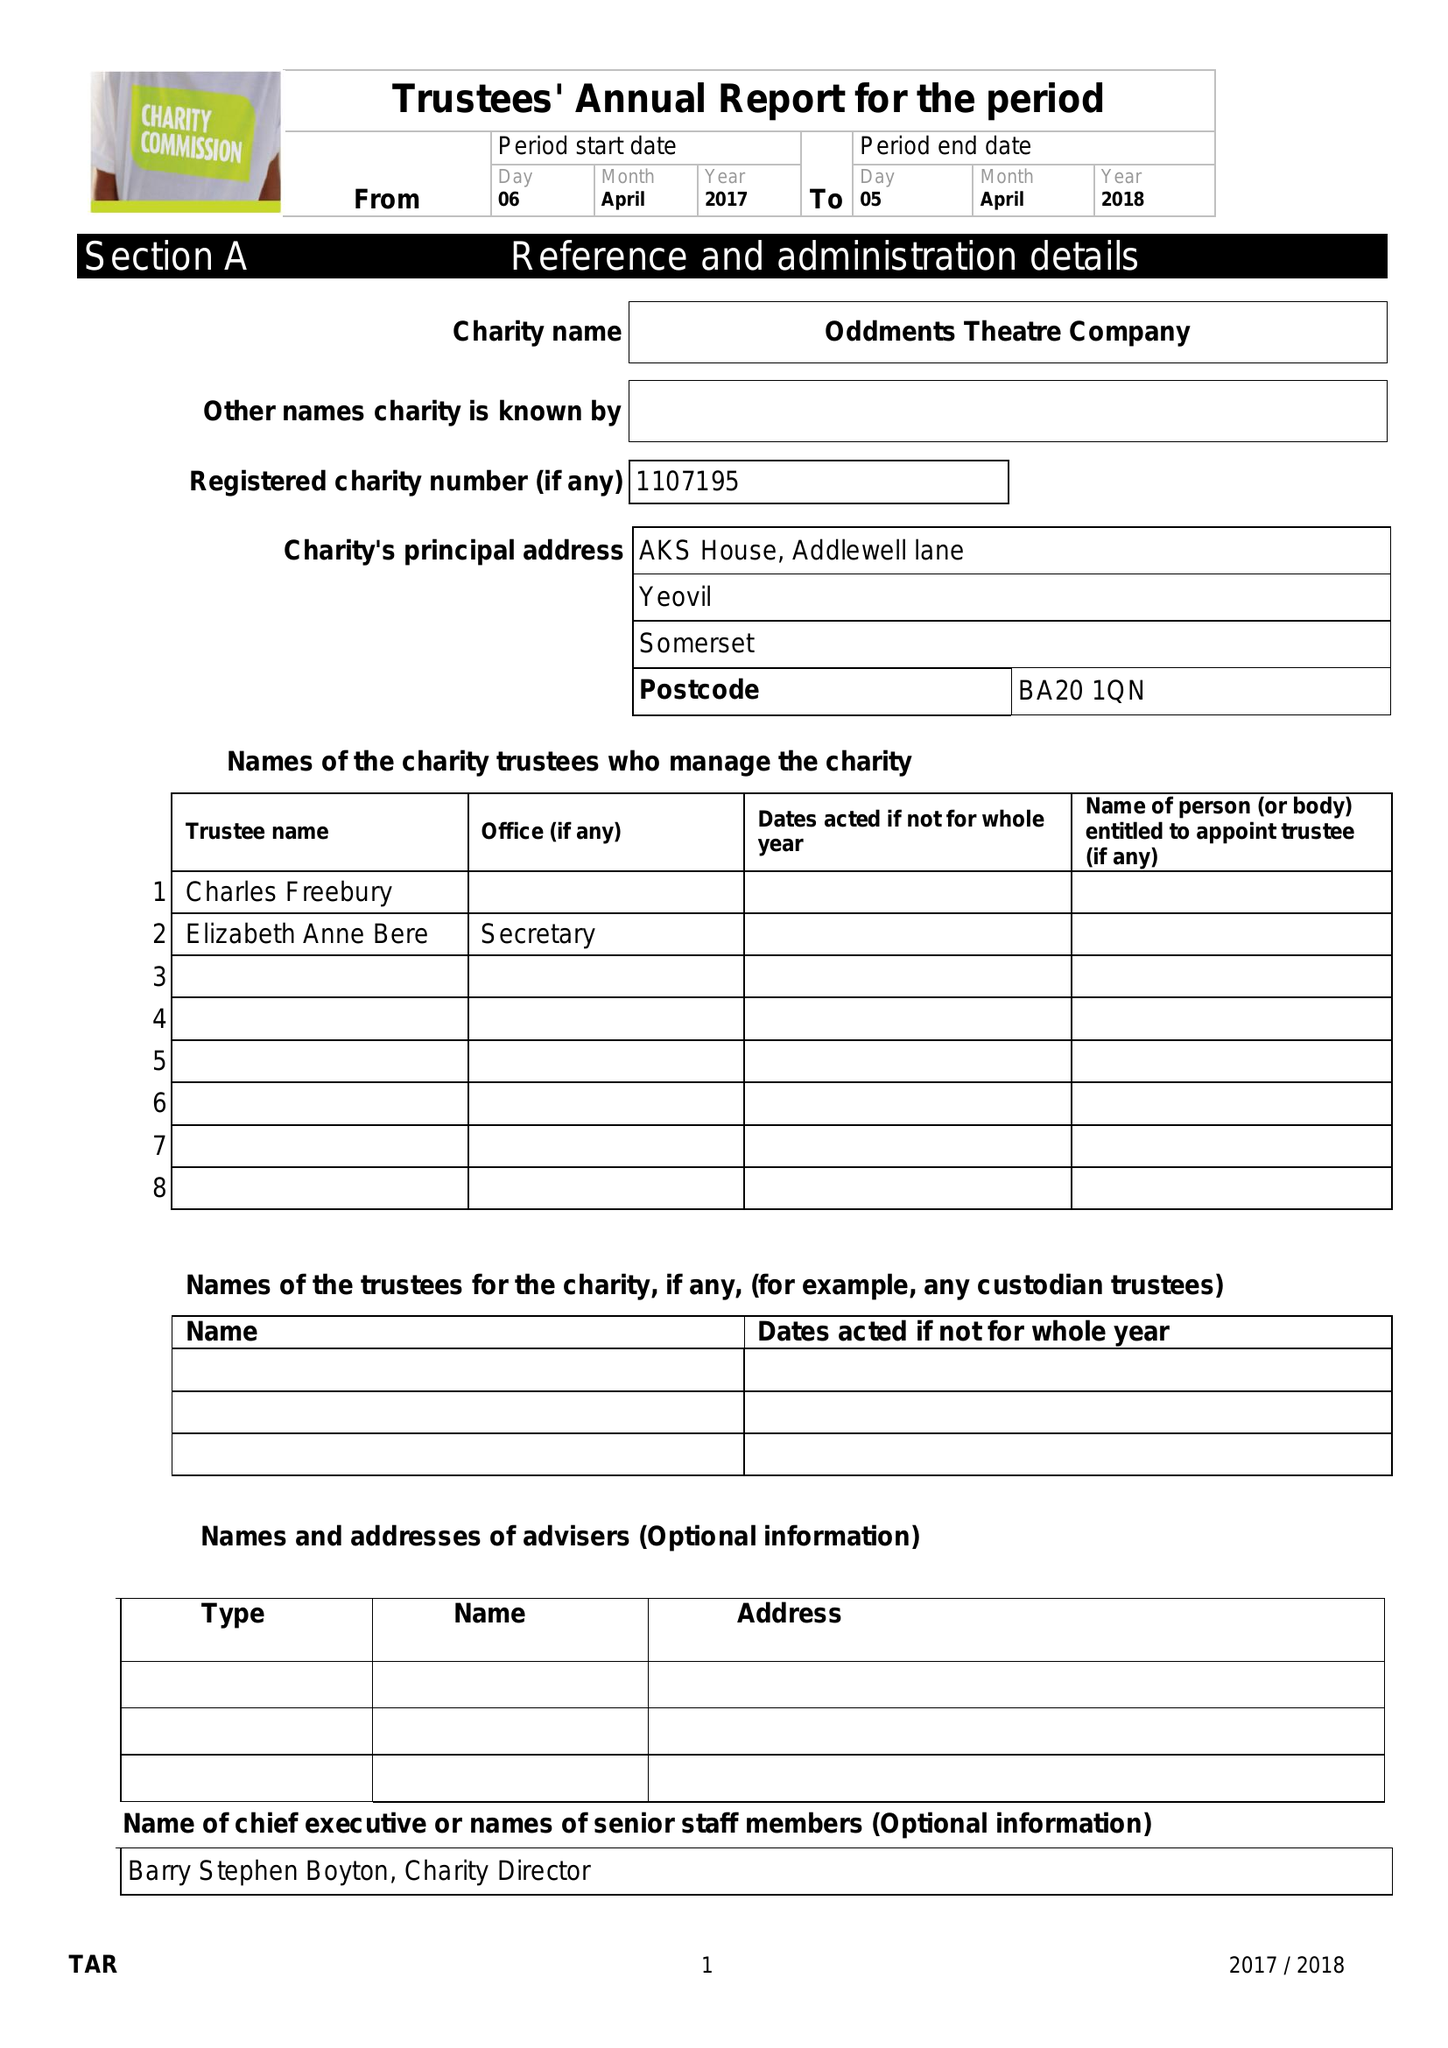What is the value for the address__post_town?
Answer the question using a single word or phrase. YEOVIL 